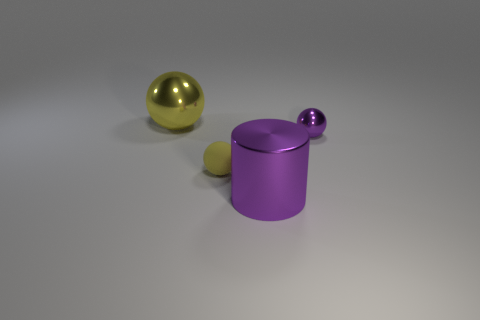There is a purple object that is in front of the purple ball; what is its shape?
Give a very brief answer. Cylinder. Are there any yellow things in front of the small metal thing?
Your answer should be compact. Yes. Is there anything else that has the same size as the yellow metal sphere?
Your answer should be very brief. Yes. There is a big sphere that is made of the same material as the tiny purple ball; what color is it?
Ensure brevity in your answer.  Yellow. There is a small thing behind the small yellow rubber object; does it have the same color as the big metal thing in front of the tiny rubber ball?
Provide a succinct answer. Yes. What number of balls are metal objects or yellow things?
Ensure brevity in your answer.  3. Are there the same number of tiny rubber spheres that are to the right of the big purple cylinder and tiny blue spheres?
Give a very brief answer. Yes. What material is the yellow thing that is on the right side of the metal thing that is left of the object in front of the small yellow rubber ball?
Offer a very short reply. Rubber. There is another big ball that is the same color as the rubber ball; what is its material?
Offer a terse response. Metal. What number of things are big things behind the purple shiny sphere or big yellow metallic balls?
Your answer should be compact. 1. 